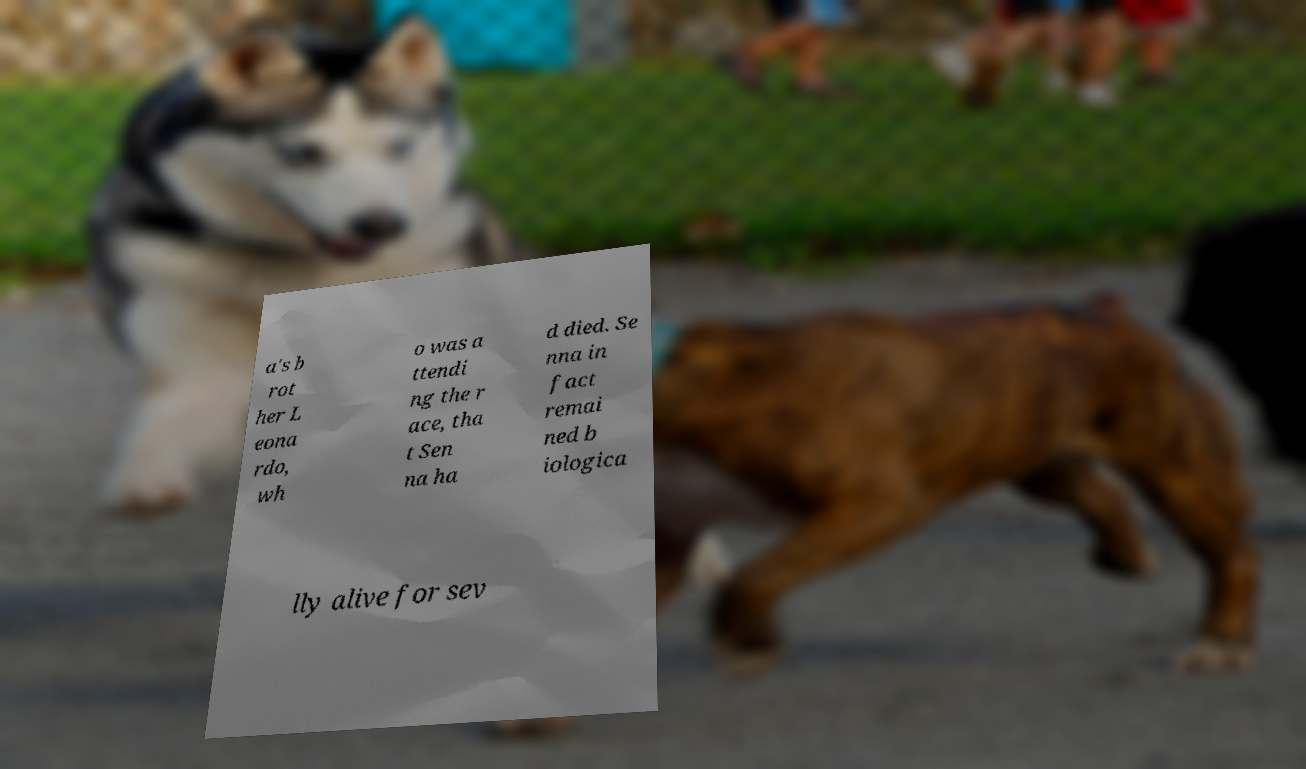There's text embedded in this image that I need extracted. Can you transcribe it verbatim? a's b rot her L eona rdo, wh o was a ttendi ng the r ace, tha t Sen na ha d died. Se nna in fact remai ned b iologica lly alive for sev 